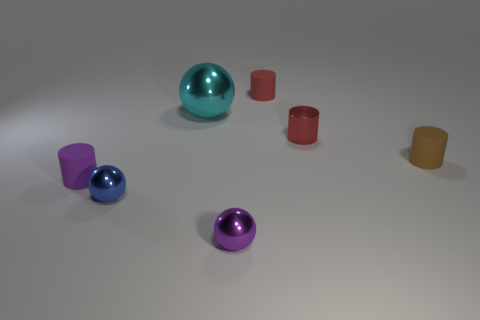What can you tell me about the lighting in this scene? The image has soft, diffuse lighting, which likely comes from an overhead light source. This subdued lighting creates gentle shadows and soft highlights on the objects, adding to the serene atmosphere of the composition. 